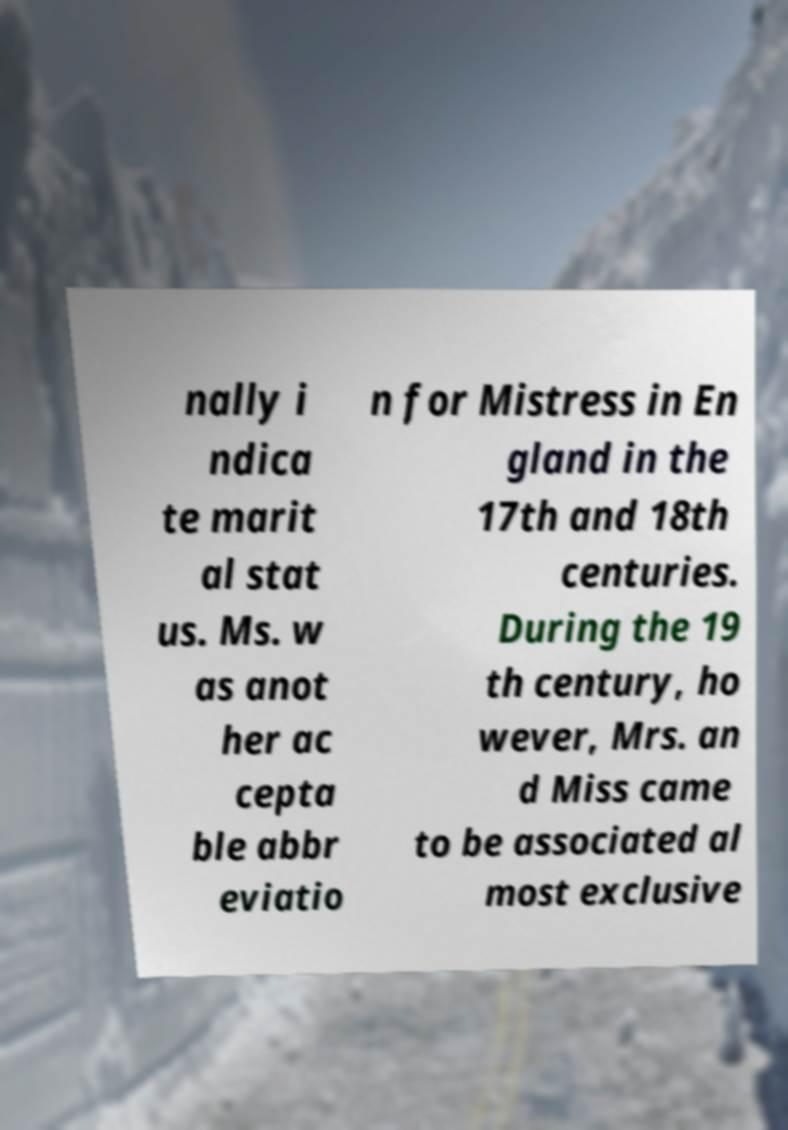Please read and relay the text visible in this image. What does it say? nally i ndica te marit al stat us. Ms. w as anot her ac cepta ble abbr eviatio n for Mistress in En gland in the 17th and 18th centuries. During the 19 th century, ho wever, Mrs. an d Miss came to be associated al most exclusive 